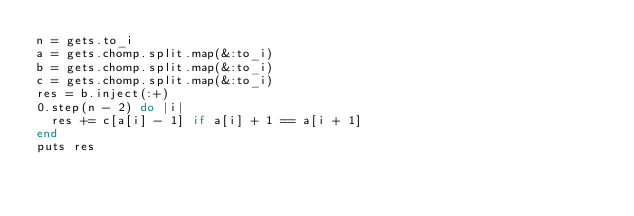Convert code to text. <code><loc_0><loc_0><loc_500><loc_500><_Ruby_>n = gets.to_i
a = gets.chomp.split.map(&:to_i)
b = gets.chomp.split.map(&:to_i)
c = gets.chomp.split.map(&:to_i)
res = b.inject(:+)
0.step(n - 2) do |i|
  res += c[a[i] - 1] if a[i] + 1 == a[i + 1]
end
puts res</code> 